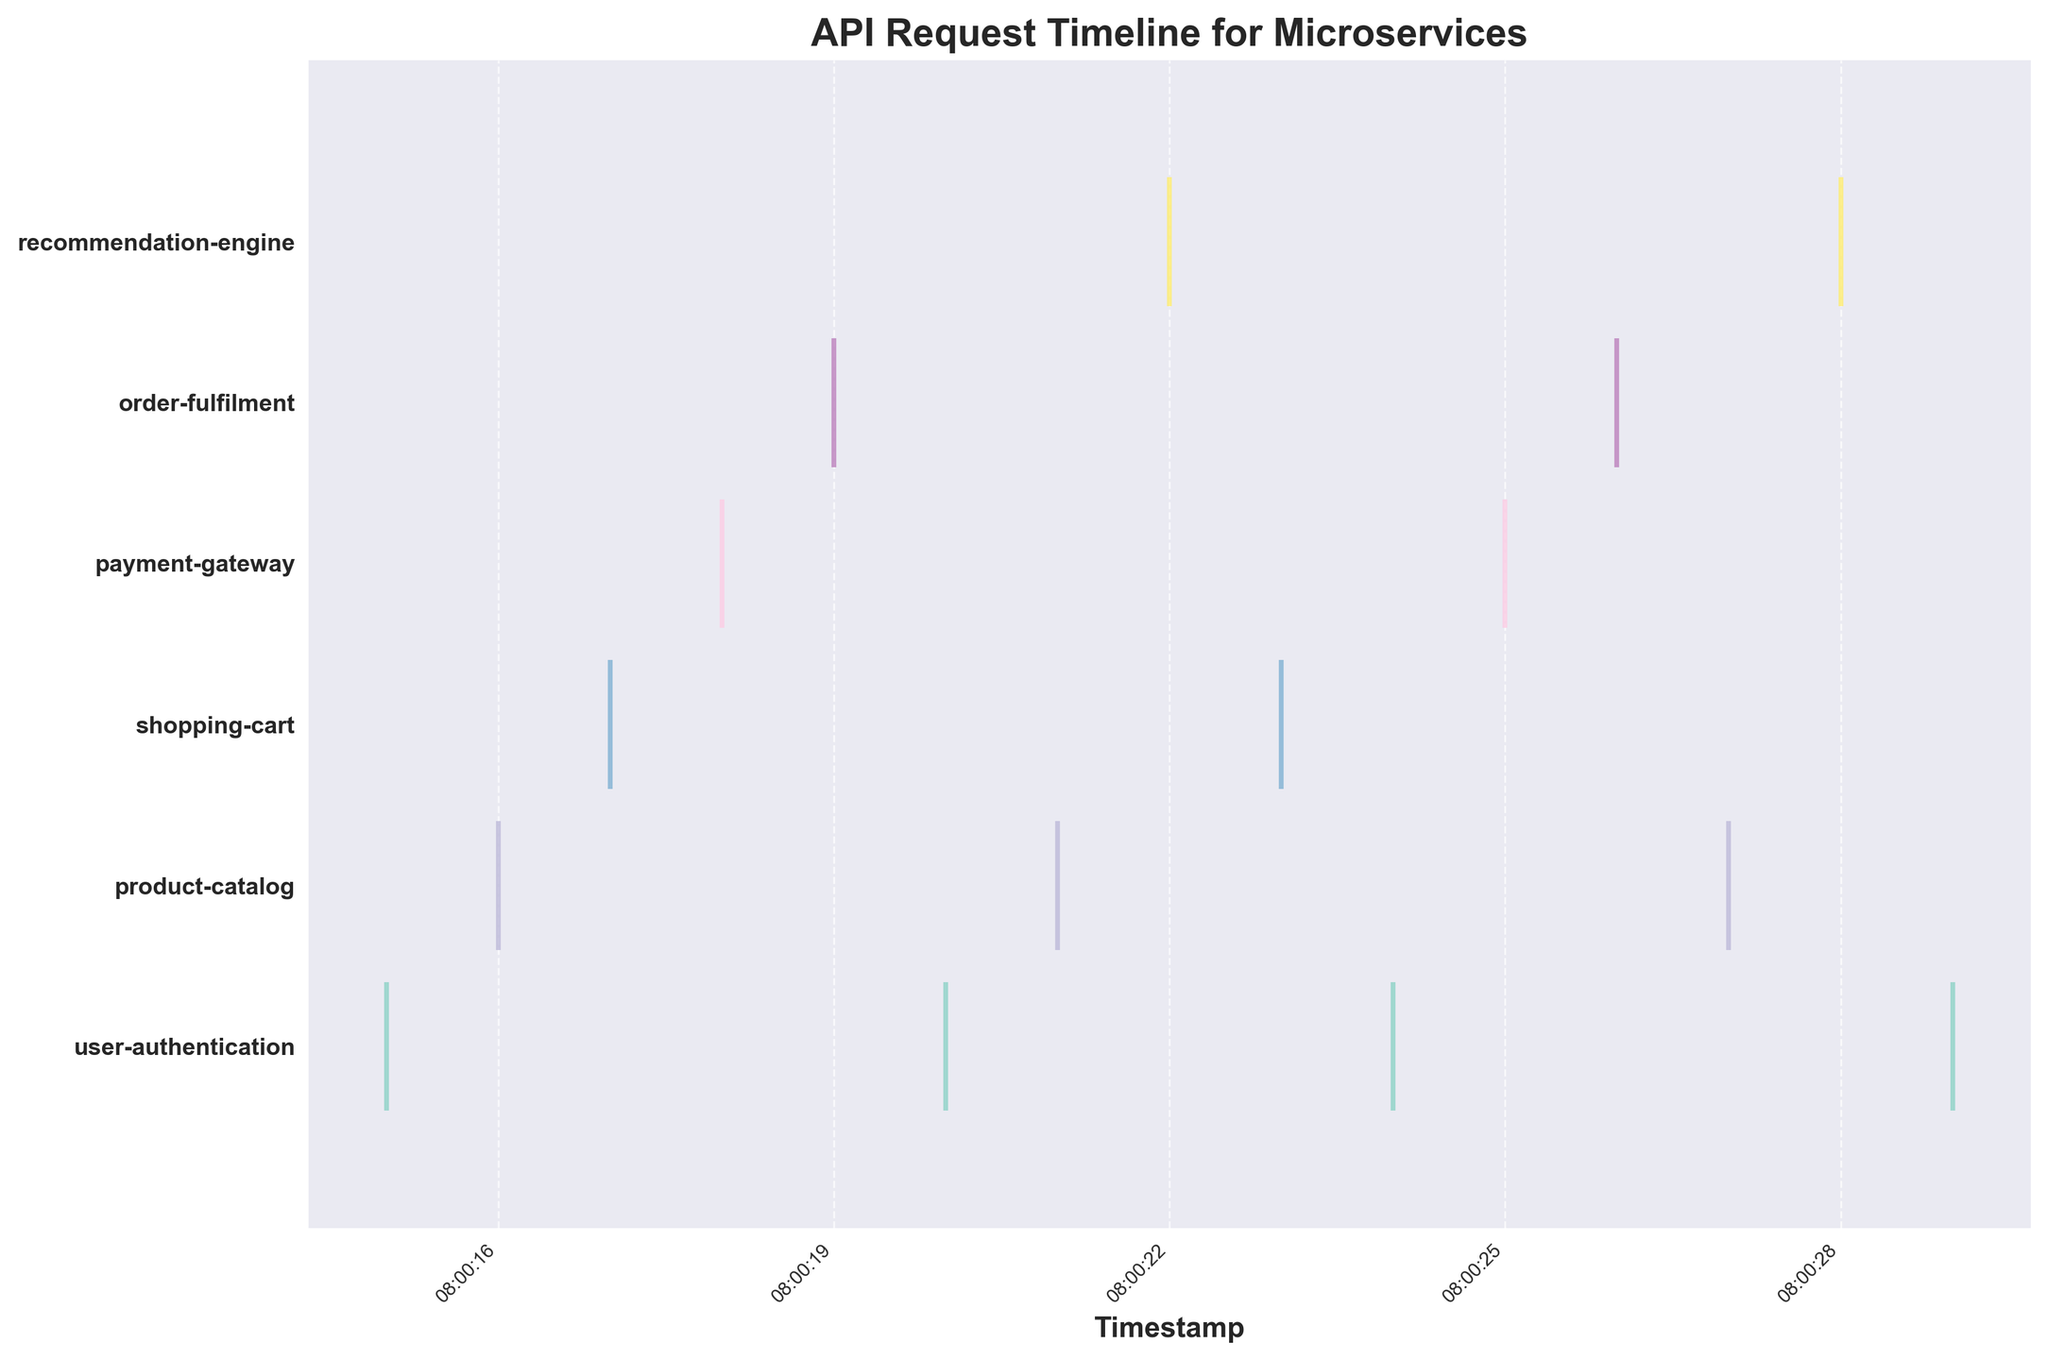What is the title of the figure? The title of the figure is located at the top and it clearly states what the plot is about.
Answer: API Request Timeline for Microservices How many unique services are shown in the figure? By counting the different y-axis labels displayed on the plot, we can determine the number of unique services.
Answer: 6 What is the color of the event line for the 'payment-gateway' service? Each service is assigned a distinct color. Look at the row labeled 'payment-gateway' for its specific line color.
Answer: Green How are the x-axis labels formatted? The x-axis labels represent timestamps. The format uses hours, minutes, and seconds.
Answer: Hours:Minutes:Seconds Which service has the most frequent events between 08:00:15 and 08:00:29? By counting the event markers for each service within the given time range, we see that 'user-authentication' has the most frequent events.
Answer: user-authentication What is the time interval between the first and the last event of the 'order-fulfilment' service? The first event timestamp for 'order-fulfilment' is at 2023-05-01 08:00:19 and the last event timestamp is at 2023-05-01 08:00:26. The time interval between them is 7 seconds.
Answer: 7 seconds How do the number of events for 'shopping-cart' compare with 'recommendation-engine'? Count the events in the 'shopping-cart' and 'recommendation-engine' rows to compare the numbers.
Answer: shopping-cart has fewer events What pattern can you observe in the events of the 'product-catalog' service? The events for 'product-catalog' are fairly evenly spaced, suggesting periodic requests.
Answer: Periodic Are there any services that do not have events occurring in consecutive seconds? Several lines show gaps between events, indicating no consecutive second events for some services. One such example is 'recommendation-engine'.
Answer: Yes 